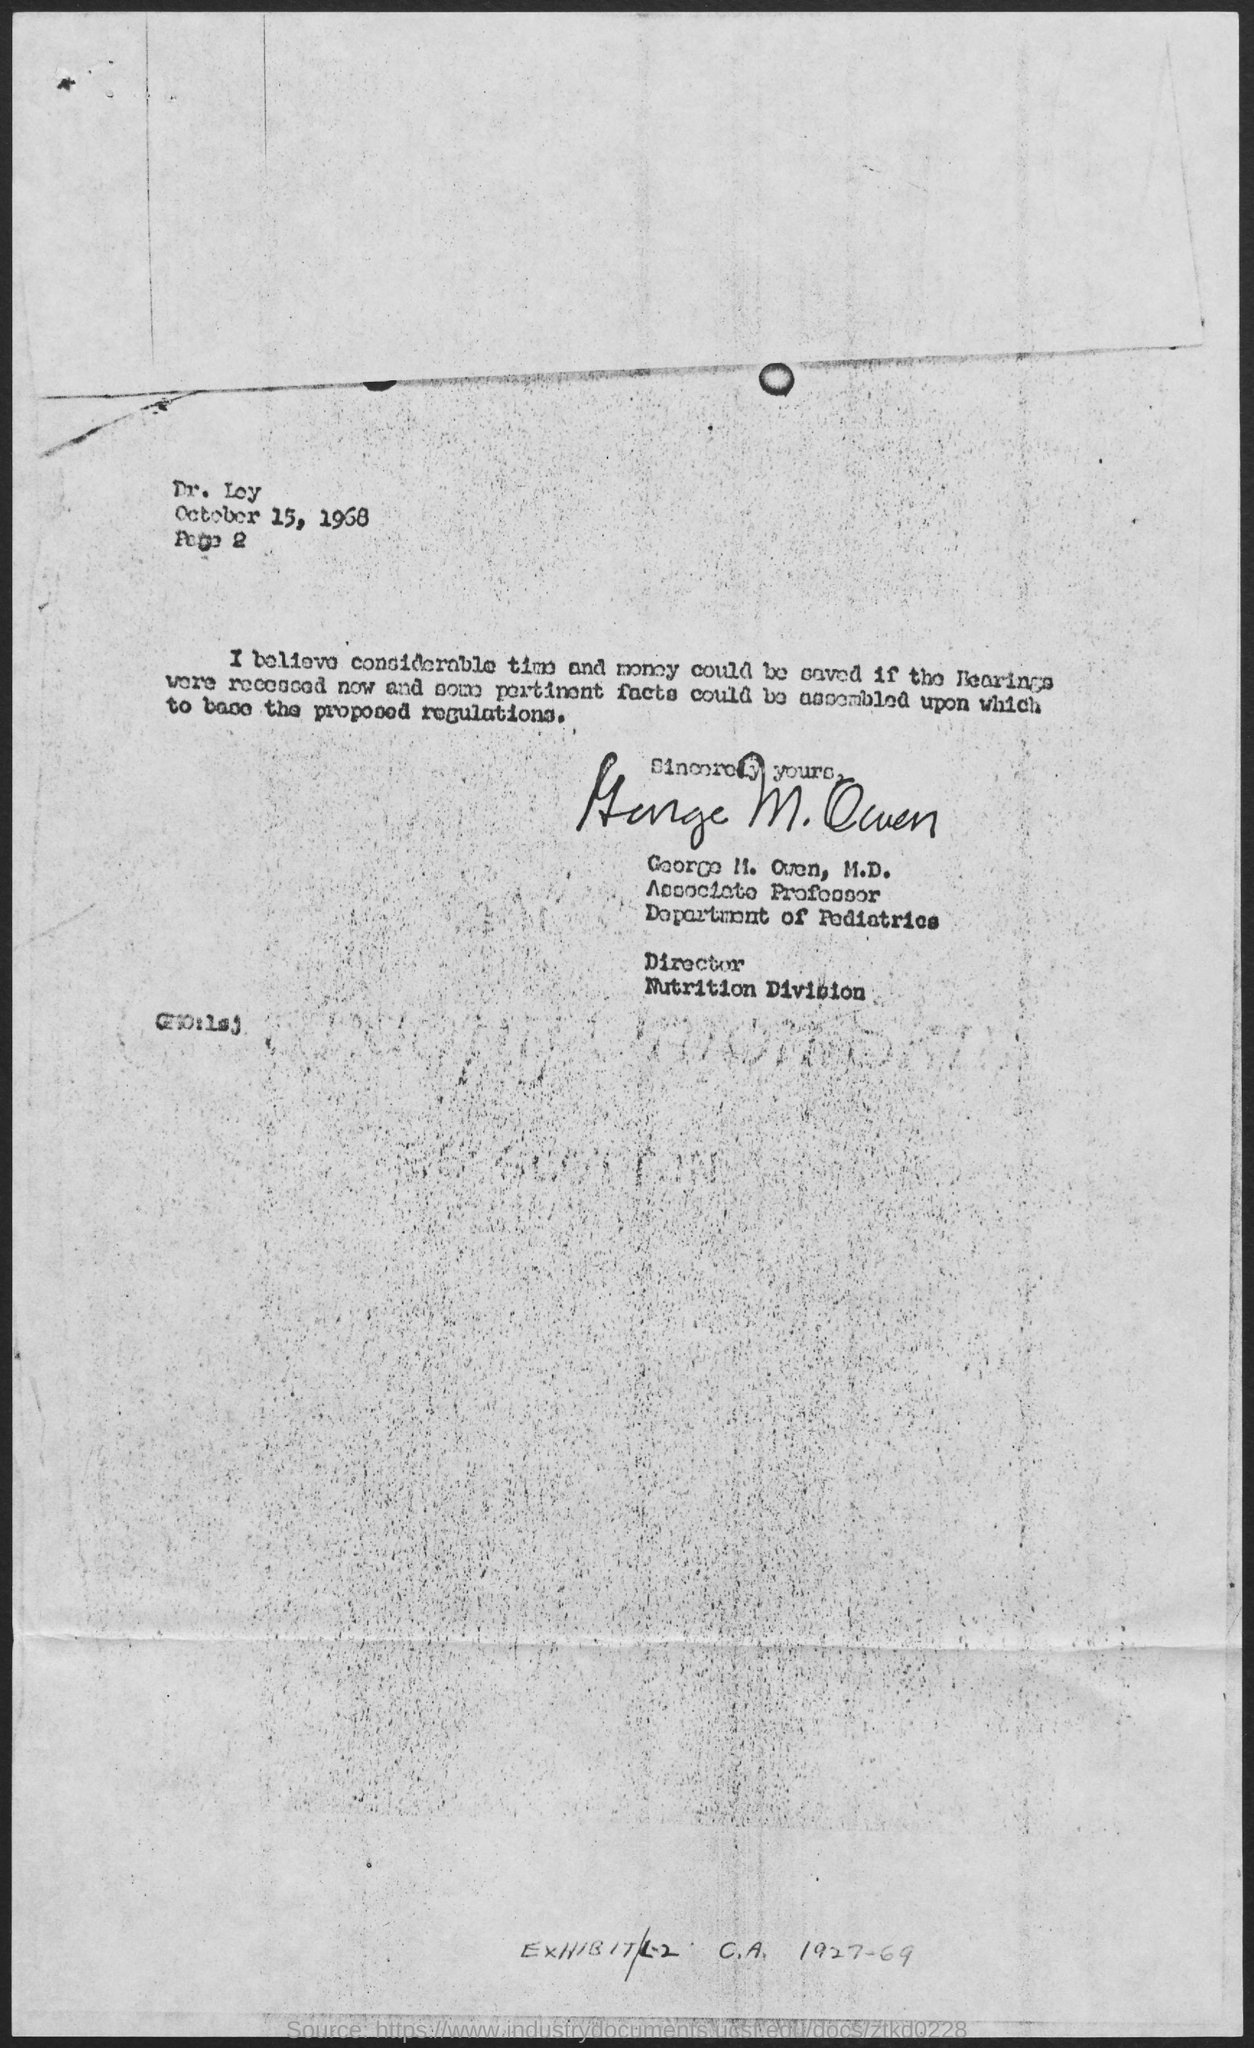What is the date mentioned in the given page ?
Your answer should be very brief. October 15, 1968. What is the designation of george m. owen ?
Your answer should be compact. Associate Professor. To which department george m. owen belongs to ?
Your answer should be compact. Department of pediatrics. 